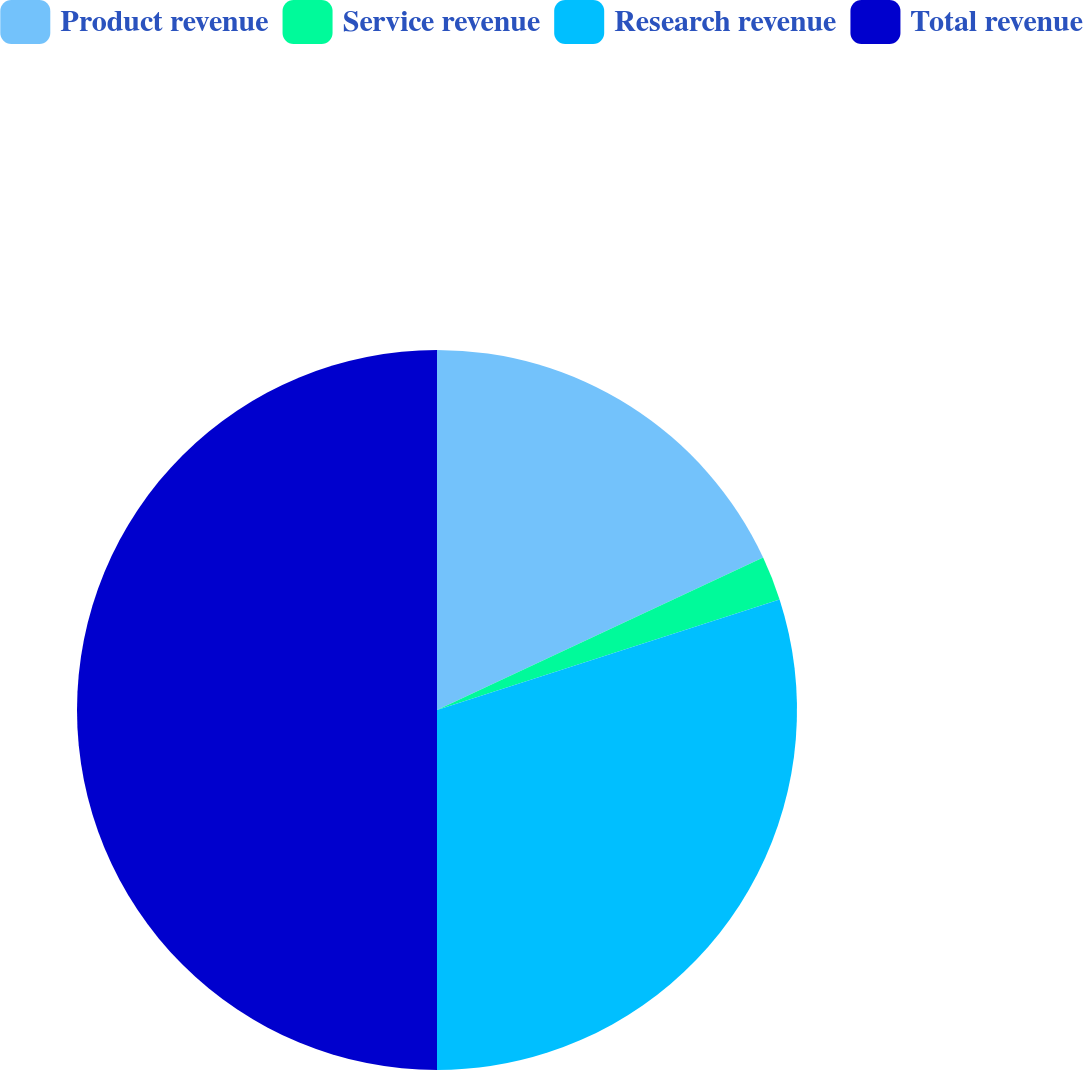Convert chart to OTSL. <chart><loc_0><loc_0><loc_500><loc_500><pie_chart><fcel>Product revenue<fcel>Service revenue<fcel>Research revenue<fcel>Total revenue<nl><fcel>18.04%<fcel>1.99%<fcel>29.97%<fcel>50.0%<nl></chart> 